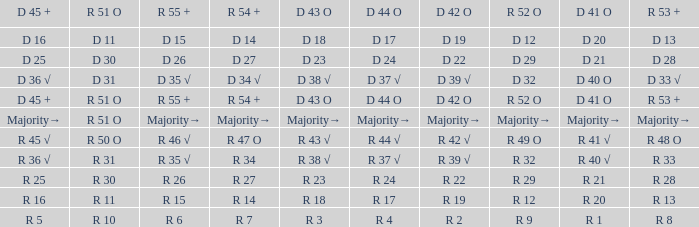Parse the table in full. {'header': ['D 45 +', 'R 51 O', 'R 55 +', 'R 54 +', 'D 43 O', 'D 44 O', 'D 42 O', 'R 52 O', 'D 41 O', 'R 53 +'], 'rows': [['D 16', 'D 11', 'D 15', 'D 14', 'D 18', 'D 17', 'D 19', 'D 12', 'D 20', 'D 13'], ['D 25', 'D 30', 'D 26', 'D 27', 'D 23', 'D 24', 'D 22', 'D 29', 'D 21', 'D 28'], ['D 36 √', 'D 31', 'D 35 √', 'D 34 √', 'D 38 √', 'D 37 √', 'D 39 √', 'D 32', 'D 40 O', 'D 33 √'], ['D 45 +', 'R 51 O', 'R 55 +', 'R 54 +', 'D 43 O', 'D 44 O', 'D 42 O', 'R 52 O', 'D 41 O', 'R 53 +'], ['Majority→', 'R 51 O', 'Majority→', 'Majority→', 'Majority→', 'Majority→', 'Majority→', 'Majority→', 'Majority→', 'Majority→'], ['R 45 √', 'R 50 O', 'R 46 √', 'R 47 O', 'R 43 √', 'R 44 √', 'R 42 √', 'R 49 O', 'R 41 √', 'R 48 O'], ['R 36 √', 'R 31', 'R 35 √', 'R 34', 'R 38 √', 'R 37 √', 'R 39 √', 'R 32', 'R 40 √', 'R 33'], ['R 25', 'R 30', 'R 26', 'R 27', 'R 23', 'R 24', 'R 22', 'R 29', 'R 21', 'R 28'], ['R 16', 'R 11', 'R 15', 'R 14', 'R 18', 'R 17', 'R 19', 'R 12', 'R 20', 'R 13'], ['R 5', 'R 10', 'R 6', 'R 7', 'R 3', 'R 4', 'R 2', 'R 9', 'R 1', 'R 8']]} What is the value of D 43 O that has a corresponding R 53 + value of r 8? R 3. 